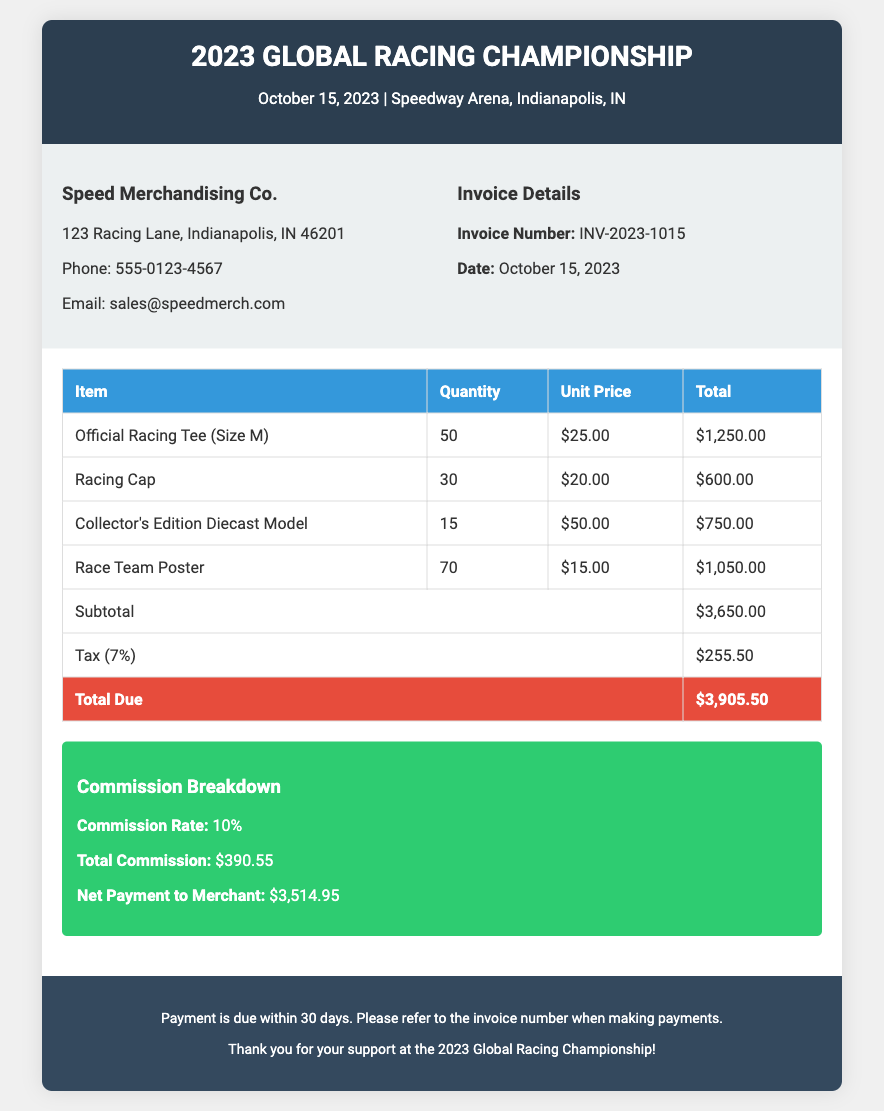what is the date of the event? The date of the event is mentioned in the invoice header as October 15, 2023.
Answer: October 15, 2023 what is the invoice number? The invoice number is listed in the invoice details section.
Answer: INV-2023-1015 how many Racing Caps were sold? The quantity of Racing Caps sold is stated in the itemized sales report.
Answer: 30 what is the subtotal amount before tax? The subtotal amount is listed before the tax calculation in the invoice.
Answer: $3,650.00 what is the commission rate applied? The commission rate can be found in the commission breakdown section.
Answer: 10% what is the total due amount? The total due amount is indicated at the bottom of the itemized sales table.
Answer: $3,905.50 how much was paid to the merchant after commission? The net payment to the merchant is found in the commission breakdown.
Answer: $3,514.95 how many Official Racing Tees were sold? The quantity of Official Racing Tees is specified in the sales report.
Answer: 50 what is the tax percentage applied to the sales? The tax percentage can be extracted from the tax line in the invoice.
Answer: 7% 